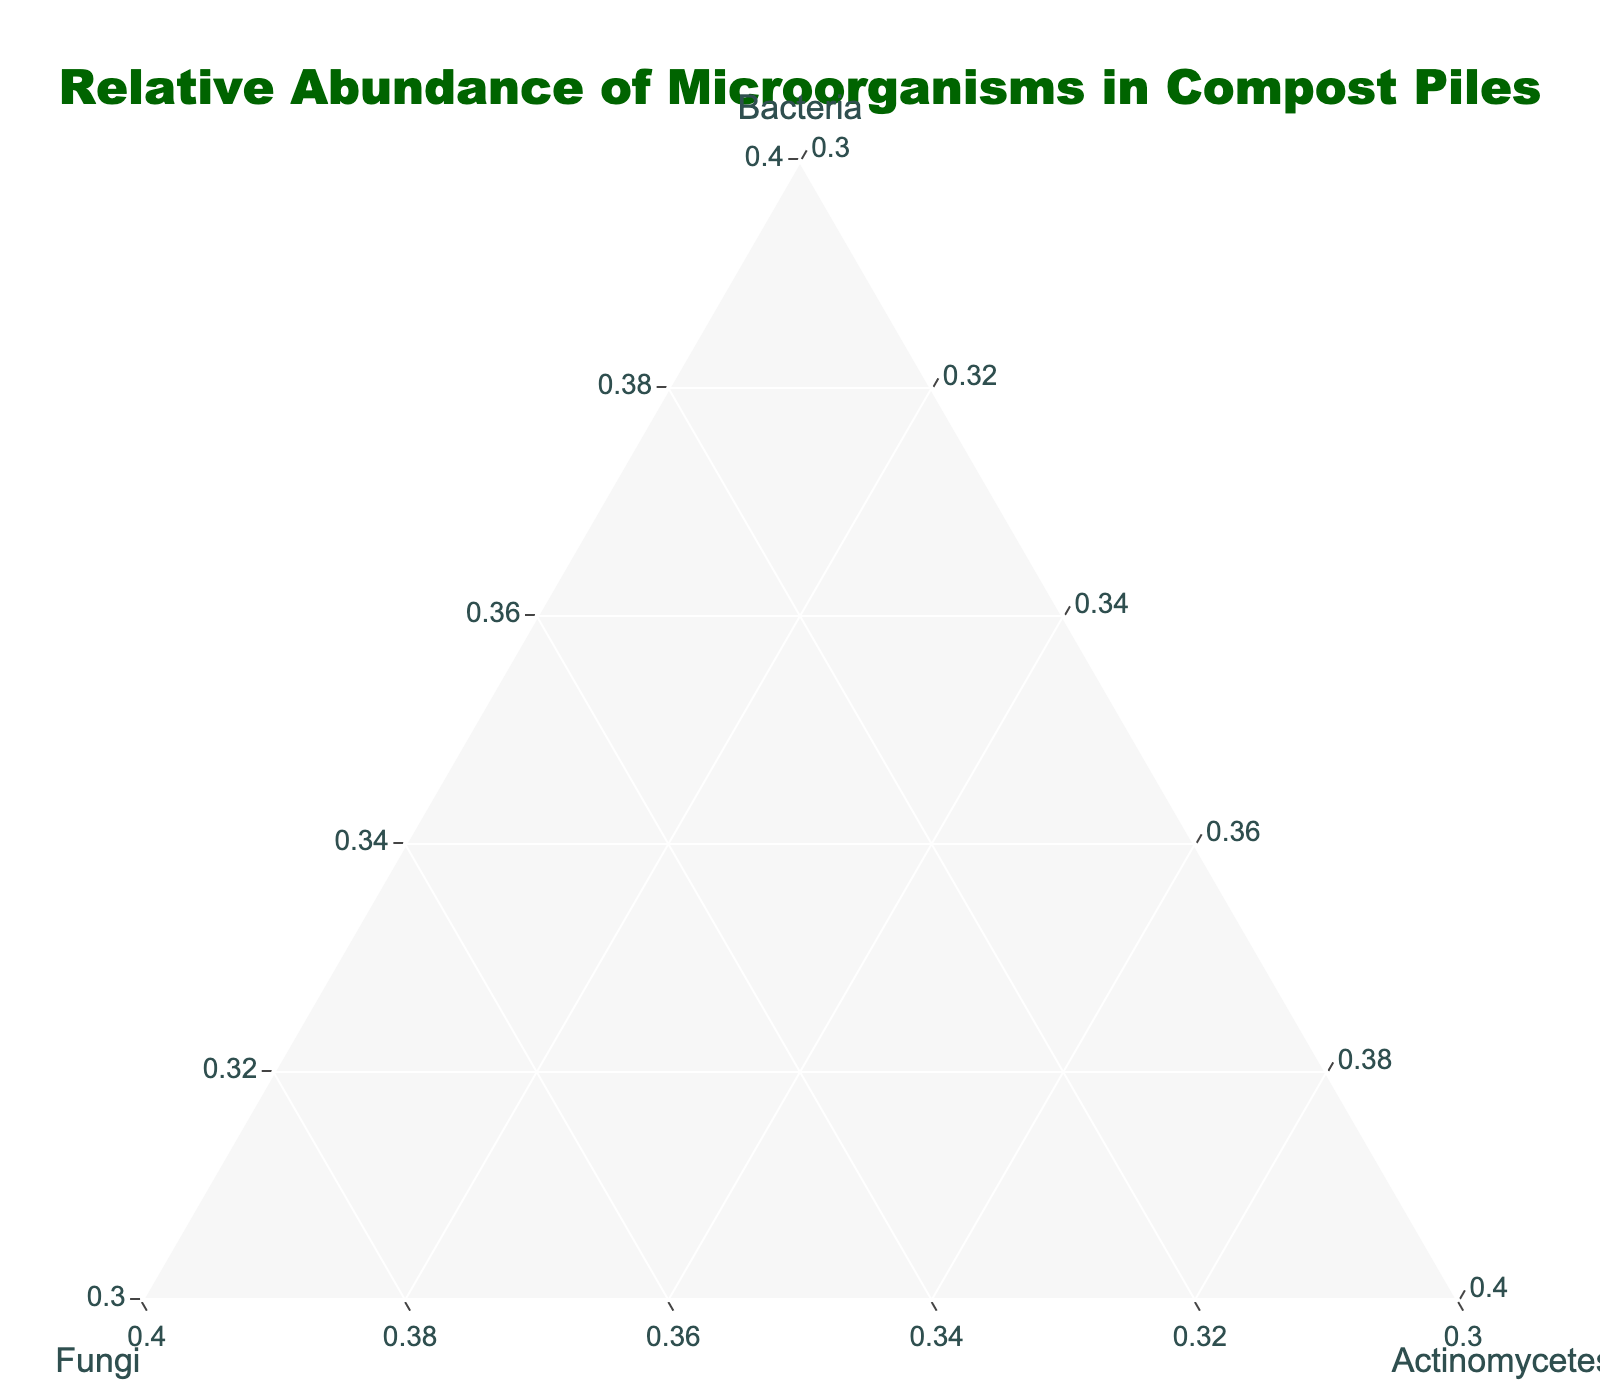What is the title of the ternary plot? The title is clearly displayed at the top of the plot, visible as text in a larger font compared to other elements.
Answer: Relative Abundance of Microorganisms in Compost Piles How many samples are represented in the plot? Each marker in the ternary plot corresponds to a sample, so counting the markers gives the total number of samples.
Answer: 10 Which sample has the highest relative abundance of fungi? Look for the marker closest to the 'Fungi' axis of the ternary plot. Identify the label of that marker.
Answer: Forest Floor Debris What is the relative abundance of actinomycetes in the sample with the lowest bacteria percentage? Locate the sample with the lowest bacteria percentage by identifying its marker. Then, find the relative abundance of actinomycetes for that sample.
Answer: 15% Which two samples have an equal proportion of bacteria, and what is that proportion? Identify clusters of markers along the plot lines where the 'Bacteria' percentage is the same and label the corresponding samples.
Answer: Grass Clippings and Vegetable Trimmings, 65% Which sample has more bacteria, Mushroom Compost or Wood Chips? Compare the positions of the markers associated with these samples along the 'Bacteria' axis and determine which is higher.
Answer: Wood Chips If you average the relative abundance of fungi from Fresh Kitchen Waste, Leaf Litter, and Aged Manure, what value do you get? Sum up the 'Fungi' percentages of these three samples and divide by 3. (20 + 35 + 25) / 3 = 80 / 3 = 26.67
Answer: 26.67 Which sample exhibits the smallest difference between the proportions of bacteria and fungi? For each sample, calculate the absolute difference between the 'Bacteria' and 'Fungi' percentages and pick the sample with the smallest value.
Answer: Aged Manure Is there any sample with an equal proportion of fungi and actinomycetes? Identify if any marker lies on the line where 'Fungi' and 'Actinomycetes' proportions are equal and check the sample label.
Answer: No Can you identify the sample with the highest concentration of bacteria and provide its relative abundance percentages of all microorganisms? Look for the marker closest to the 'Bacteria' axis and note its label and the percentages of 'Bacteria', 'Fungi', and 'Actinomycetes'.
Answer: Food Scraps, Bacteria: 75%, Fungi: 10%, Actinomycetes: 15% 